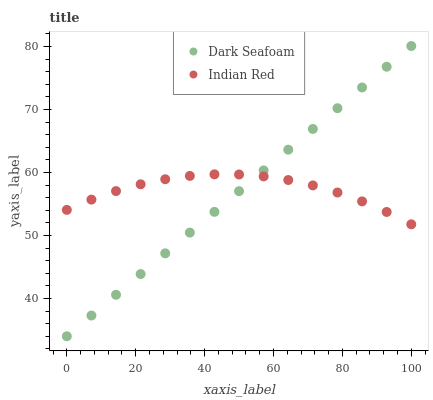Does Dark Seafoam have the minimum area under the curve?
Answer yes or no. Yes. Does Indian Red have the maximum area under the curve?
Answer yes or no. Yes. Does Indian Red have the minimum area under the curve?
Answer yes or no. No. Is Dark Seafoam the smoothest?
Answer yes or no. Yes. Is Indian Red the roughest?
Answer yes or no. Yes. Is Indian Red the smoothest?
Answer yes or no. No. Does Dark Seafoam have the lowest value?
Answer yes or no. Yes. Does Indian Red have the lowest value?
Answer yes or no. No. Does Dark Seafoam have the highest value?
Answer yes or no. Yes. Does Indian Red have the highest value?
Answer yes or no. No. Does Dark Seafoam intersect Indian Red?
Answer yes or no. Yes. Is Dark Seafoam less than Indian Red?
Answer yes or no. No. Is Dark Seafoam greater than Indian Red?
Answer yes or no. No. 